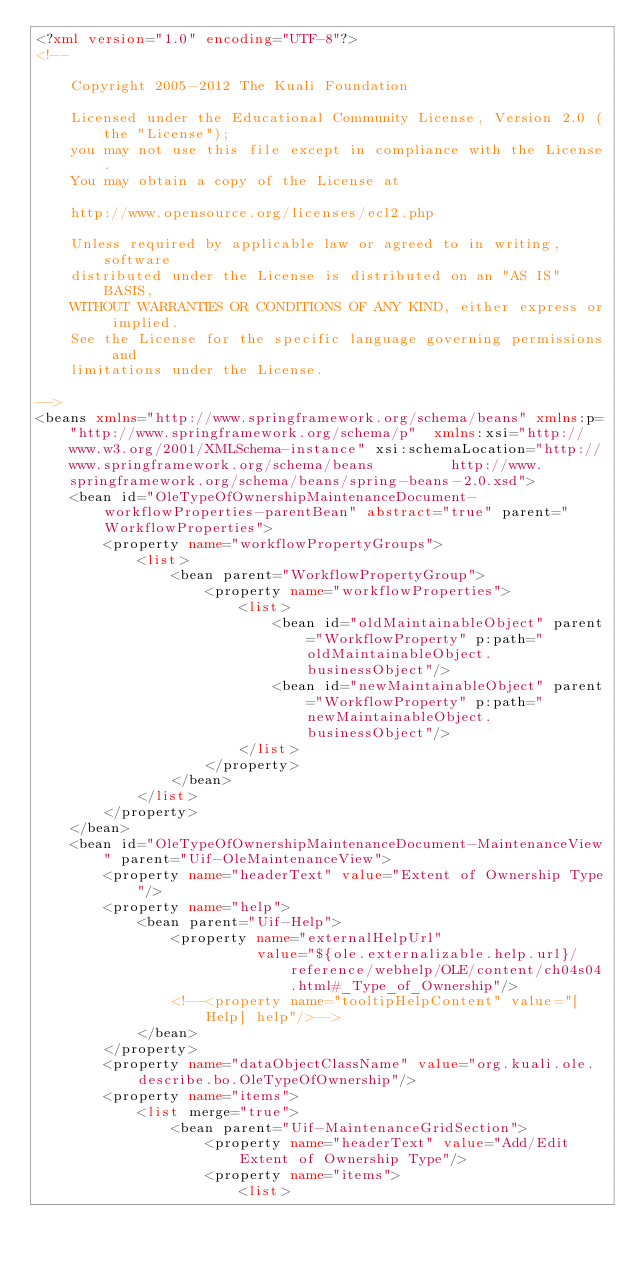Convert code to text. <code><loc_0><loc_0><loc_500><loc_500><_XML_><?xml version="1.0" encoding="UTF-8"?>
<!--

    Copyright 2005-2012 The Kuali Foundation

    Licensed under the Educational Community License, Version 2.0 (the "License");
    you may not use this file except in compliance with the License.
    You may obtain a copy of the License at

    http://www.opensource.org/licenses/ecl2.php

    Unless required by applicable law or agreed to in writing, software
    distributed under the License is distributed on an "AS IS" BASIS,
    WITHOUT WARRANTIES OR CONDITIONS OF ANY KIND, either express or implied.
    See the License for the specific language governing permissions and
    limitations under the License.

-->
<beans xmlns="http://www.springframework.org/schema/beans" xmlns:p="http://www.springframework.org/schema/p"  xmlns:xsi="http://www.w3.org/2001/XMLSchema-instance" xsi:schemaLocation="http://www.springframework.org/schema/beans         http://www.springframework.org/schema/beans/spring-beans-2.0.xsd">
    <bean id="OleTypeOfOwnershipMaintenanceDocument-workflowProperties-parentBean" abstract="true" parent="WorkflowProperties">
        <property name="workflowPropertyGroups">
            <list>
                <bean parent="WorkflowPropertyGroup">
                    <property name="workflowProperties">
                        <list>
                            <bean id="oldMaintainableObject" parent="WorkflowProperty" p:path="oldMaintainableObject.businessObject"/>
                            <bean id="newMaintainableObject" parent="WorkflowProperty" p:path="newMaintainableObject.businessObject"/>
                        </list>
                    </property>
                </bean>
            </list>
        </property>
    </bean>
    <bean id="OleTypeOfOwnershipMaintenanceDocument-MaintenanceView" parent="Uif-OleMaintenanceView">
        <property name="headerText" value="Extent of Ownership Type"/>
        <property name="help">
            <bean parent="Uif-Help">
                <property name="externalHelpUrl"
                          value="${ole.externalizable.help.url}/reference/webhelp/OLE/content/ch04s04.html#_Type_of_Ownership"/>
                <!--<property name="tooltipHelpContent" value="[Help] help"/>-->
            </bean>
        </property>
        <property name="dataObjectClassName" value="org.kuali.ole.describe.bo.OleTypeOfOwnership"/>
        <property name="items">
            <list merge="true">
                <bean parent="Uif-MaintenanceGridSection">
                    <property name="headerText" value="Add/Edit Extent of Ownership Type"/>
                    <property name="items">
                        <list></code> 